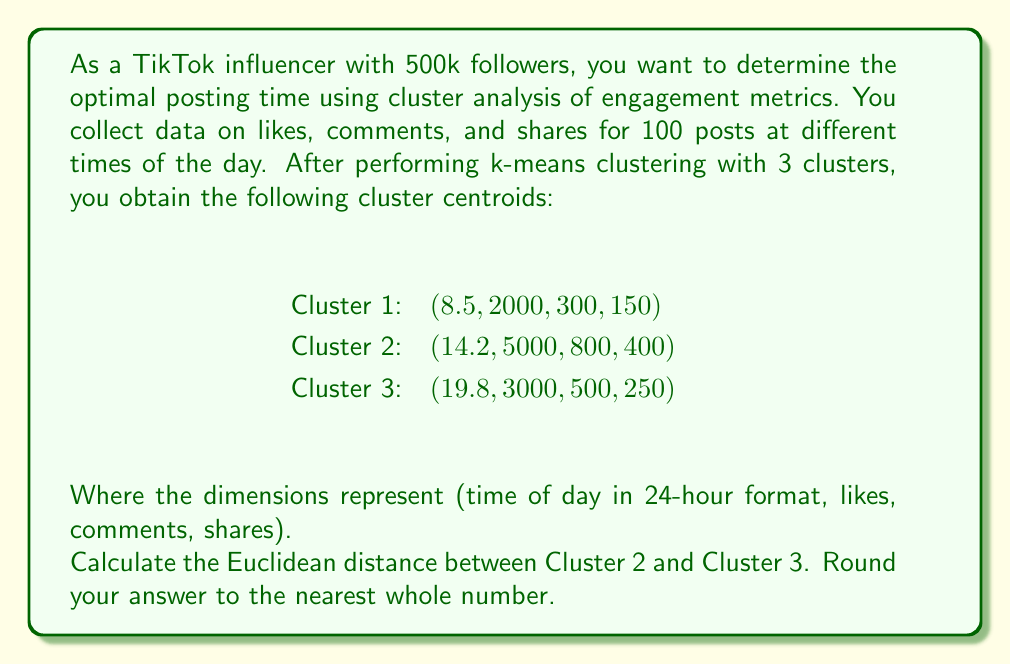Provide a solution to this math problem. To solve this problem, we need to use the Euclidean distance formula in 4-dimensional space. The Euclidean distance between two points in n-dimensional space is given by:

$$d = \sqrt{\sum_{i=1}^n (x_i - y_i)^2}$$

Where $x_i$ and $y_i$ are the coordinates of the two points in the i-th dimension.

Let's calculate the difference for each dimension:

1. Time: $14.2 - 19.8 = -5.6$
2. Likes: $5000 - 3000 = 2000$
3. Comments: $800 - 500 = 300$
4. Shares: $400 - 250 = 150$

Now, we square each difference:

1. $(-5.6)^2 = 31.36$
2. $2000^2 = 4,000,000$
3. $300^2 = 90,000$
4. $150^2 = 22,500$

Sum these squared differences:

$$31.36 + 4,000,000 + 90,000 + 22,500 = 4,112,531.36$$

Take the square root:

$$\sqrt{4,112,531.36} \approx 2027.94$$

Rounding to the nearest whole number gives us 2028.
Answer: 2028 